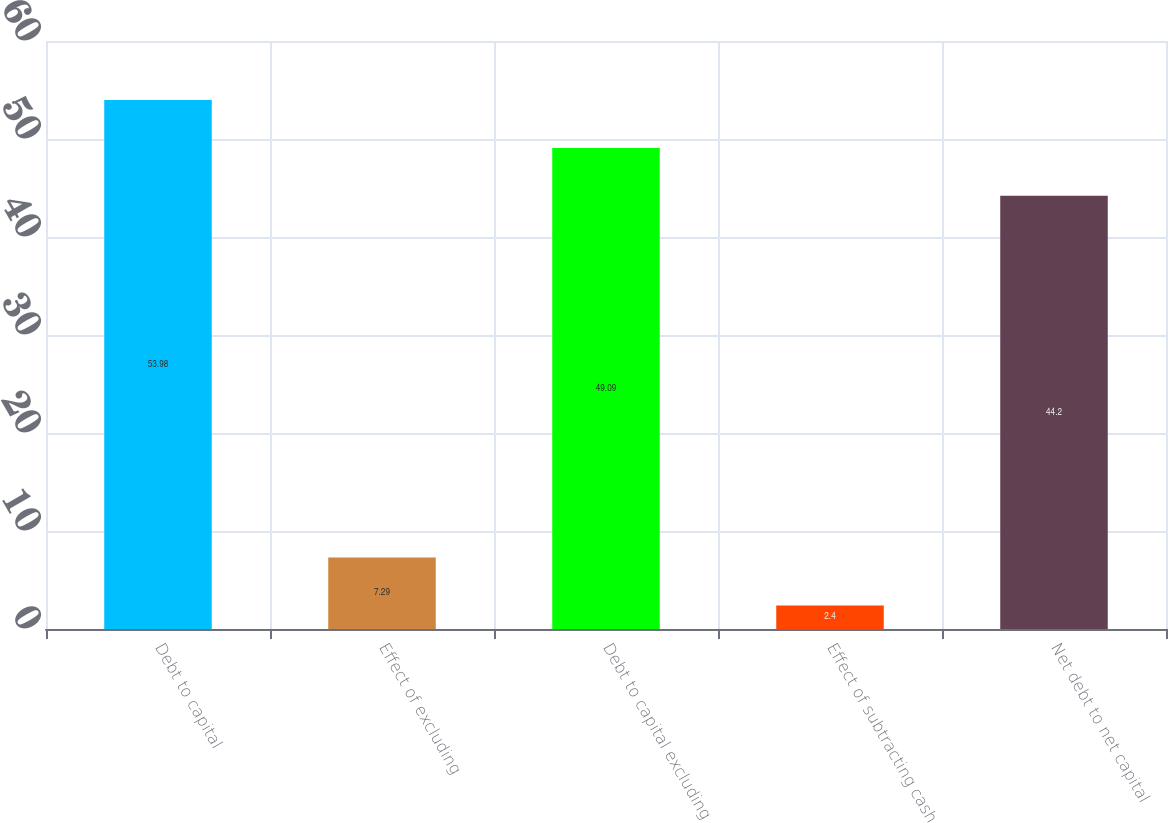<chart> <loc_0><loc_0><loc_500><loc_500><bar_chart><fcel>Debt to capital<fcel>Effect of excluding<fcel>Debt to capital excluding<fcel>Effect of subtracting cash<fcel>Net debt to net capital<nl><fcel>53.98<fcel>7.29<fcel>49.09<fcel>2.4<fcel>44.2<nl></chart> 